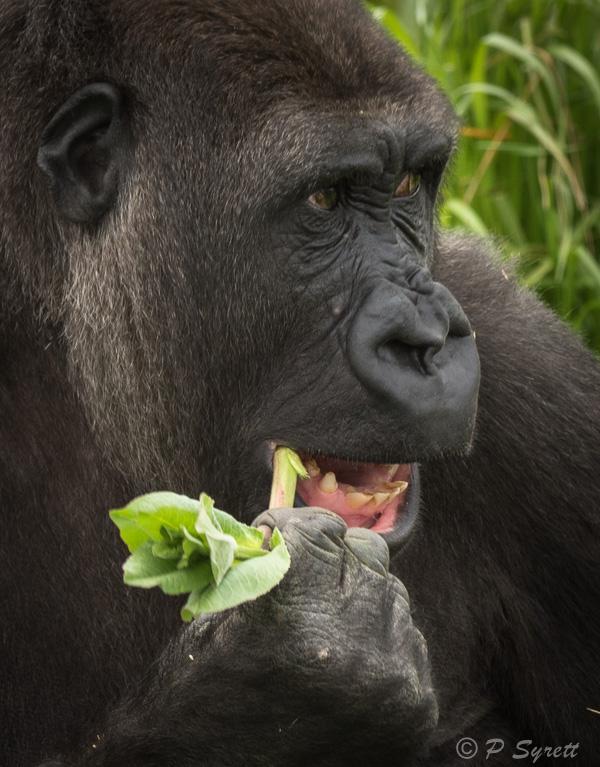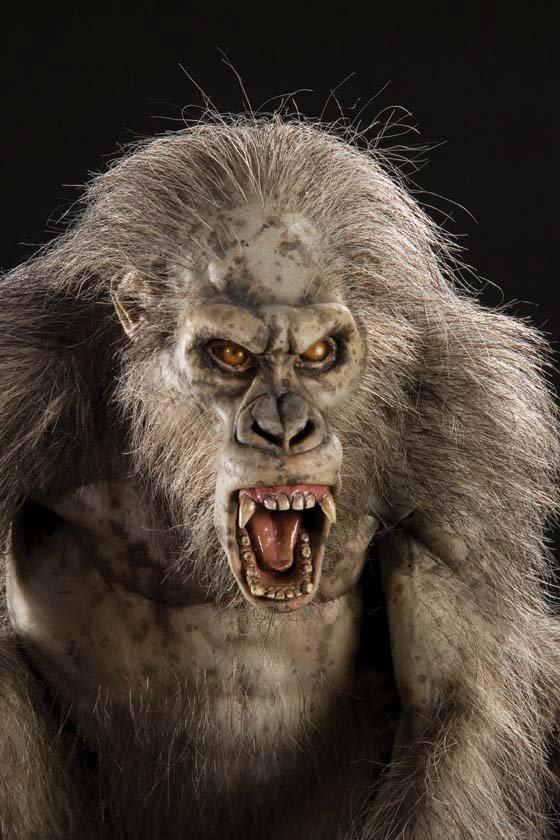The first image is the image on the left, the second image is the image on the right. Assess this claim about the two images: "In at least one image there are two gorilla one adult holding a single baby.". Correct or not? Answer yes or no. No. The first image is the image on the left, the second image is the image on the right. Considering the images on both sides, is "One image shows an adult gorilla cradling a baby gorilla at its chest with at least one arm." valid? Answer yes or no. No. 